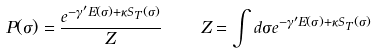<formula> <loc_0><loc_0><loc_500><loc_500>P ( \sigma ) = \frac { e ^ { - \gamma ^ { \prime } E ( \sigma ) + \kappa S _ { T } ( \sigma ) } } { Z } \quad Z = \int d \sigma e ^ { - \gamma ^ { \prime } E ( \sigma ) + \kappa S _ { T } ( \sigma ) }</formula> 